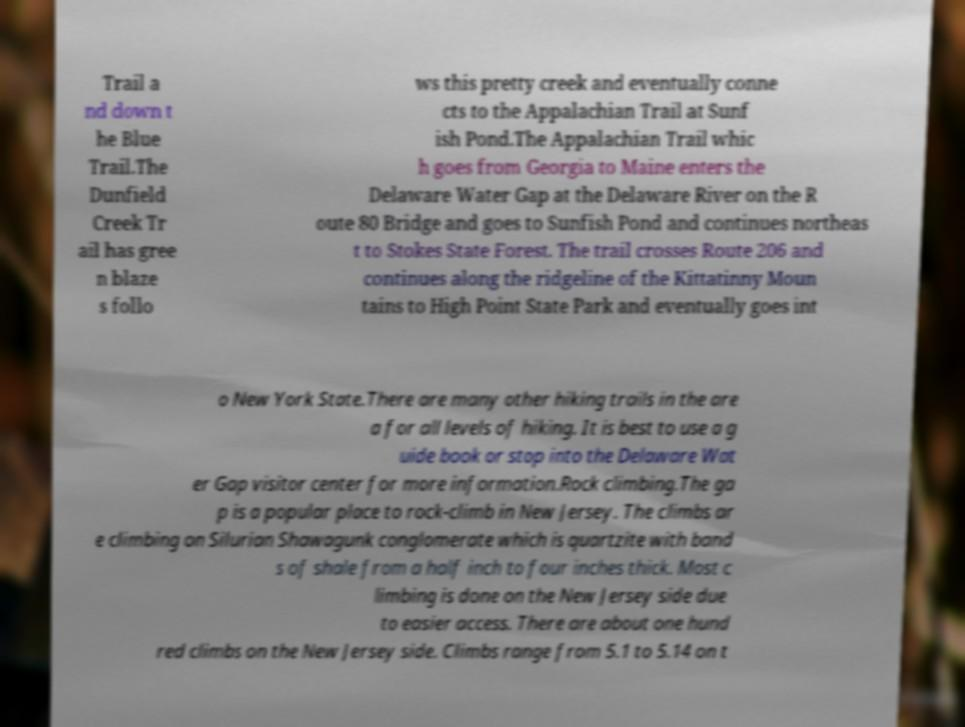What messages or text are displayed in this image? I need them in a readable, typed format. Trail a nd down t he Blue Trail.The Dunfield Creek Tr ail has gree n blaze s follo ws this pretty creek and eventually conne cts to the Appalachian Trail at Sunf ish Pond.The Appalachian Trail whic h goes from Georgia to Maine enters the Delaware Water Gap at the Delaware River on the R oute 80 Bridge and goes to Sunfish Pond and continues northeas t to Stokes State Forest. The trail crosses Route 206 and continues along the ridgeline of the Kittatinny Moun tains to High Point State Park and eventually goes int o New York State.There are many other hiking trails in the are a for all levels of hiking. It is best to use a g uide book or stop into the Delaware Wat er Gap visitor center for more information.Rock climbing.The ga p is a popular place to rock-climb in New Jersey. The climbs ar e climbing on Silurian Shawagunk conglomerate which is quartzite with band s of shale from a half inch to four inches thick. Most c limbing is done on the New Jersey side due to easier access. There are about one hund red climbs on the New Jersey side. Climbs range from 5.1 to 5.14 on t 